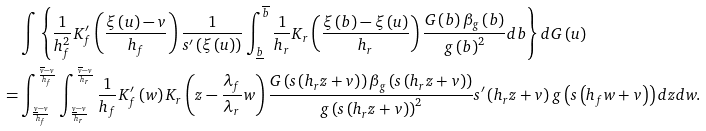<formula> <loc_0><loc_0><loc_500><loc_500>& \int \left \{ \frac { 1 } { h _ { f } ^ { 2 } } K _ { f } ^ { \prime } \left ( \frac { \xi \left ( u \right ) - v } { h _ { f } } \right ) \frac { 1 } { s ^ { \prime } \left ( \xi \left ( u \right ) \right ) } \int _ { \underline { b } } ^ { \overline { b } } \frac { 1 } { h _ { r } } K _ { r } \left ( \frac { \xi \left ( b \right ) - \xi \left ( u \right ) } { h _ { r } } \right ) \frac { G \left ( b \right ) \beta _ { g } \left ( b \right ) } { g \left ( b \right ) ^ { 2 } } d b \right \} d G \left ( u \right ) \\ = & \int _ { \frac { \underline { v } - v } { h _ { f } } } ^ { \frac { \overline { v } - v } { h _ { f } } } \int _ { \frac { \underline { v } - v } { h _ { r } } } ^ { \frac { \overline { v } - v } { h _ { r } } } \frac { 1 } { h _ { f } } K _ { f } ^ { \prime } \left ( w \right ) K _ { r } \left ( z - \frac { \lambda _ { f } } { \lambda _ { r } } w \right ) \frac { G \left ( s \left ( h _ { r } z + v \right ) \right ) \beta _ { g } \left ( s \left ( h _ { r } z + v \right ) \right ) } { g \left ( s \left ( h _ { r } z + v \right ) \right ) ^ { 2 } } s ^ { \prime } \left ( h _ { r } z + v \right ) g \left ( s \left ( h _ { f } w + v \right ) \right ) d z d w .</formula> 